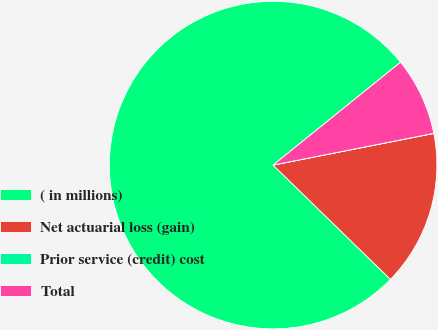Convert chart to OTSL. <chart><loc_0><loc_0><loc_500><loc_500><pie_chart><fcel>( in millions)<fcel>Net actuarial loss (gain)<fcel>Prior service (credit) cost<fcel>Total<nl><fcel>76.91%<fcel>15.39%<fcel>0.01%<fcel>7.7%<nl></chart> 